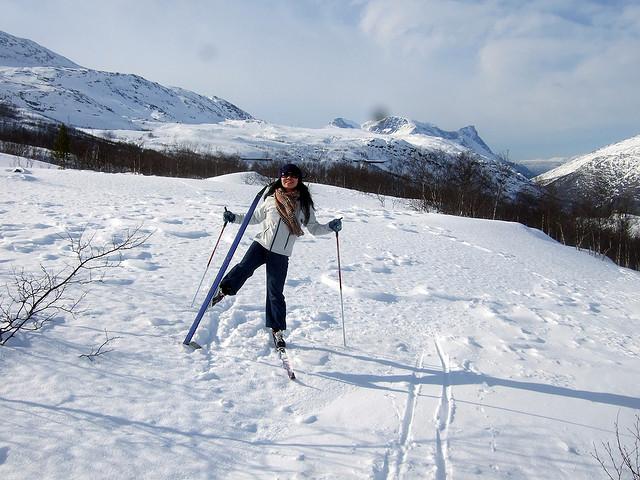How many people are in this photo?
Give a very brief answer. 1. Is this person skiing towards the camera?
Give a very brief answer. Yes. Is she having fun?
Give a very brief answer. Yes. Is this on a mountain?
Quick response, please. Yes. What season is this?
Give a very brief answer. Winter. 